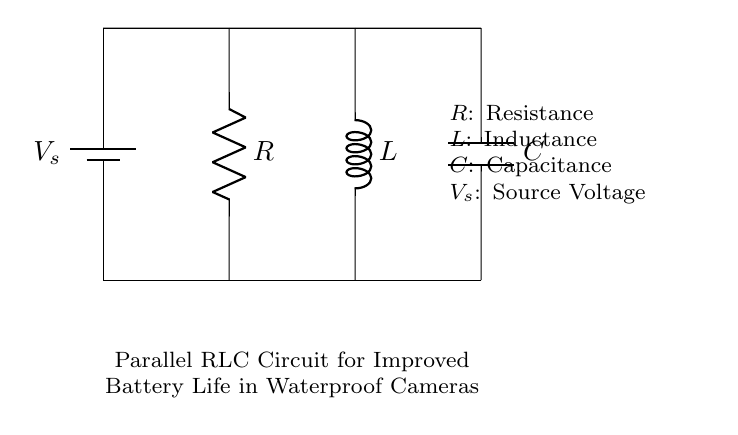What components are present in the circuit? The circuit consists of a resistor, inductor, and capacitor, all arranged in parallel. This is evident from the labels in the diagram indicating R, L, and C, respectively.
Answer: Resistor, Inductor, Capacitor What is the purpose of the battery in this circuit? The battery provides the source voltage necessary for the operation of the circuit. It is represented at the top of the diagram as V_s.
Answer: Source Voltage How does the arrangement of components affect the overall impedance? In a parallel RLC circuit, the total impedance is reduced compared to individual impedances, as the current can take multiple paths. The presence of the inductor and capacitor allows for resonance conditions that can maximize or minimize impedance based on frequency.
Answer: Reduced impedance What is the role of the capacitor in this circuit? The capacitor stores electrical energy and can release it when needed, affecting the phase angle between voltage and current. This can smooth the voltage fluctuations and assist in extending battery life during high-demand photography activities in water.
Answer: Energy storage How does this circuit improve battery life for waterproof cameras? By utilizing a parallel RLC configuration, the circuit manages voltage and current more efficiently, allowing for higher instantaneous current delivery without significant drops. The reactive components can reduce power loss and extend operational time in demanding conditions.
Answer: More efficient power management What happens to the voltage across each component in a parallel circuit? Each component in a parallel circuit experiences the same voltage across it, which is equal to the source voltage. This ensures that the energy delivered to each component is consistent and helps manage power distribution effectively.
Answer: Same as source voltage 